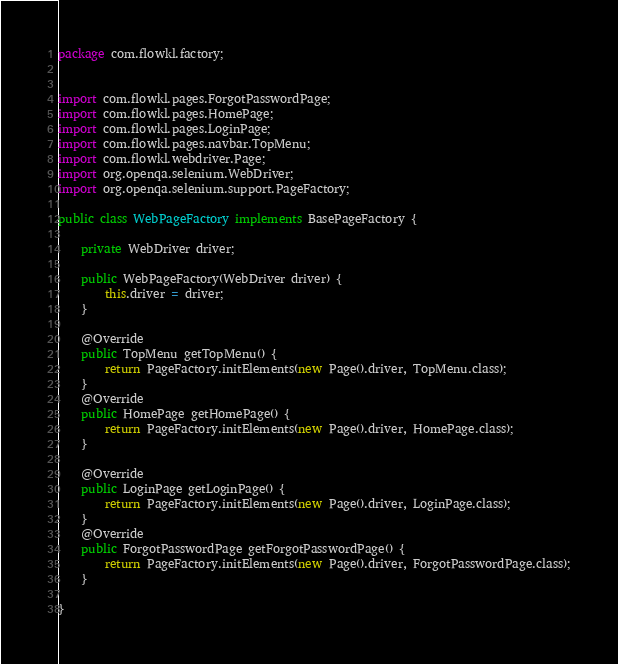Convert code to text. <code><loc_0><loc_0><loc_500><loc_500><_Java_>package com.flowkl.factory;


import com.flowkl.pages.ForgotPasswordPage;
import com.flowkl.pages.HomePage;
import com.flowkl.pages.LoginPage;
import com.flowkl.pages.navbar.TopMenu;
import com.flowkl.webdriver.Page;
import org.openqa.selenium.WebDriver;
import org.openqa.selenium.support.PageFactory;

public class WebPageFactory implements BasePageFactory {

	private WebDriver driver;

	public WebPageFactory(WebDriver driver) {
		this.driver = driver;
	}

	@Override
	public TopMenu getTopMenu() {
		return PageFactory.initElements(new Page().driver, TopMenu.class);
	}
	@Override
	public HomePage getHomePage() {
		return PageFactory.initElements(new Page().driver, HomePage.class);
	}

	@Override
	public LoginPage getLoginPage() {
		return PageFactory.initElements(new Page().driver, LoginPage.class);
	}
	@Override
	public ForgotPasswordPage getForgotPasswordPage() {
		return PageFactory.initElements(new Page().driver, ForgotPasswordPage.class);
	}

}</code> 